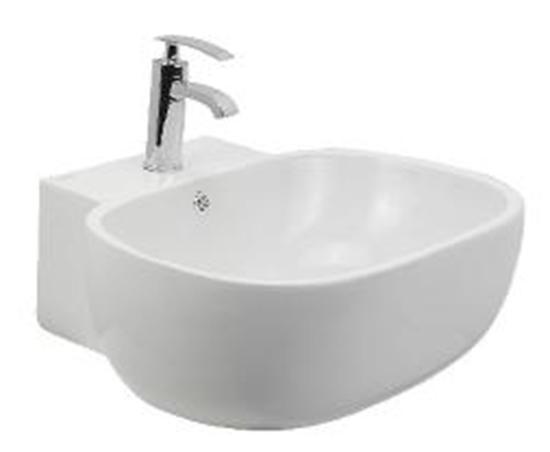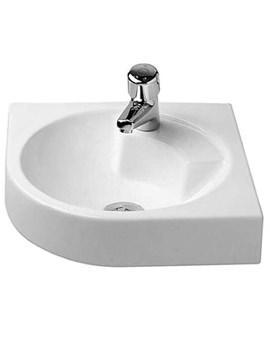The first image is the image on the left, the second image is the image on the right. Examine the images to the left and right. Is the description "There is a square sink in one of the images." accurate? Answer yes or no. No. 